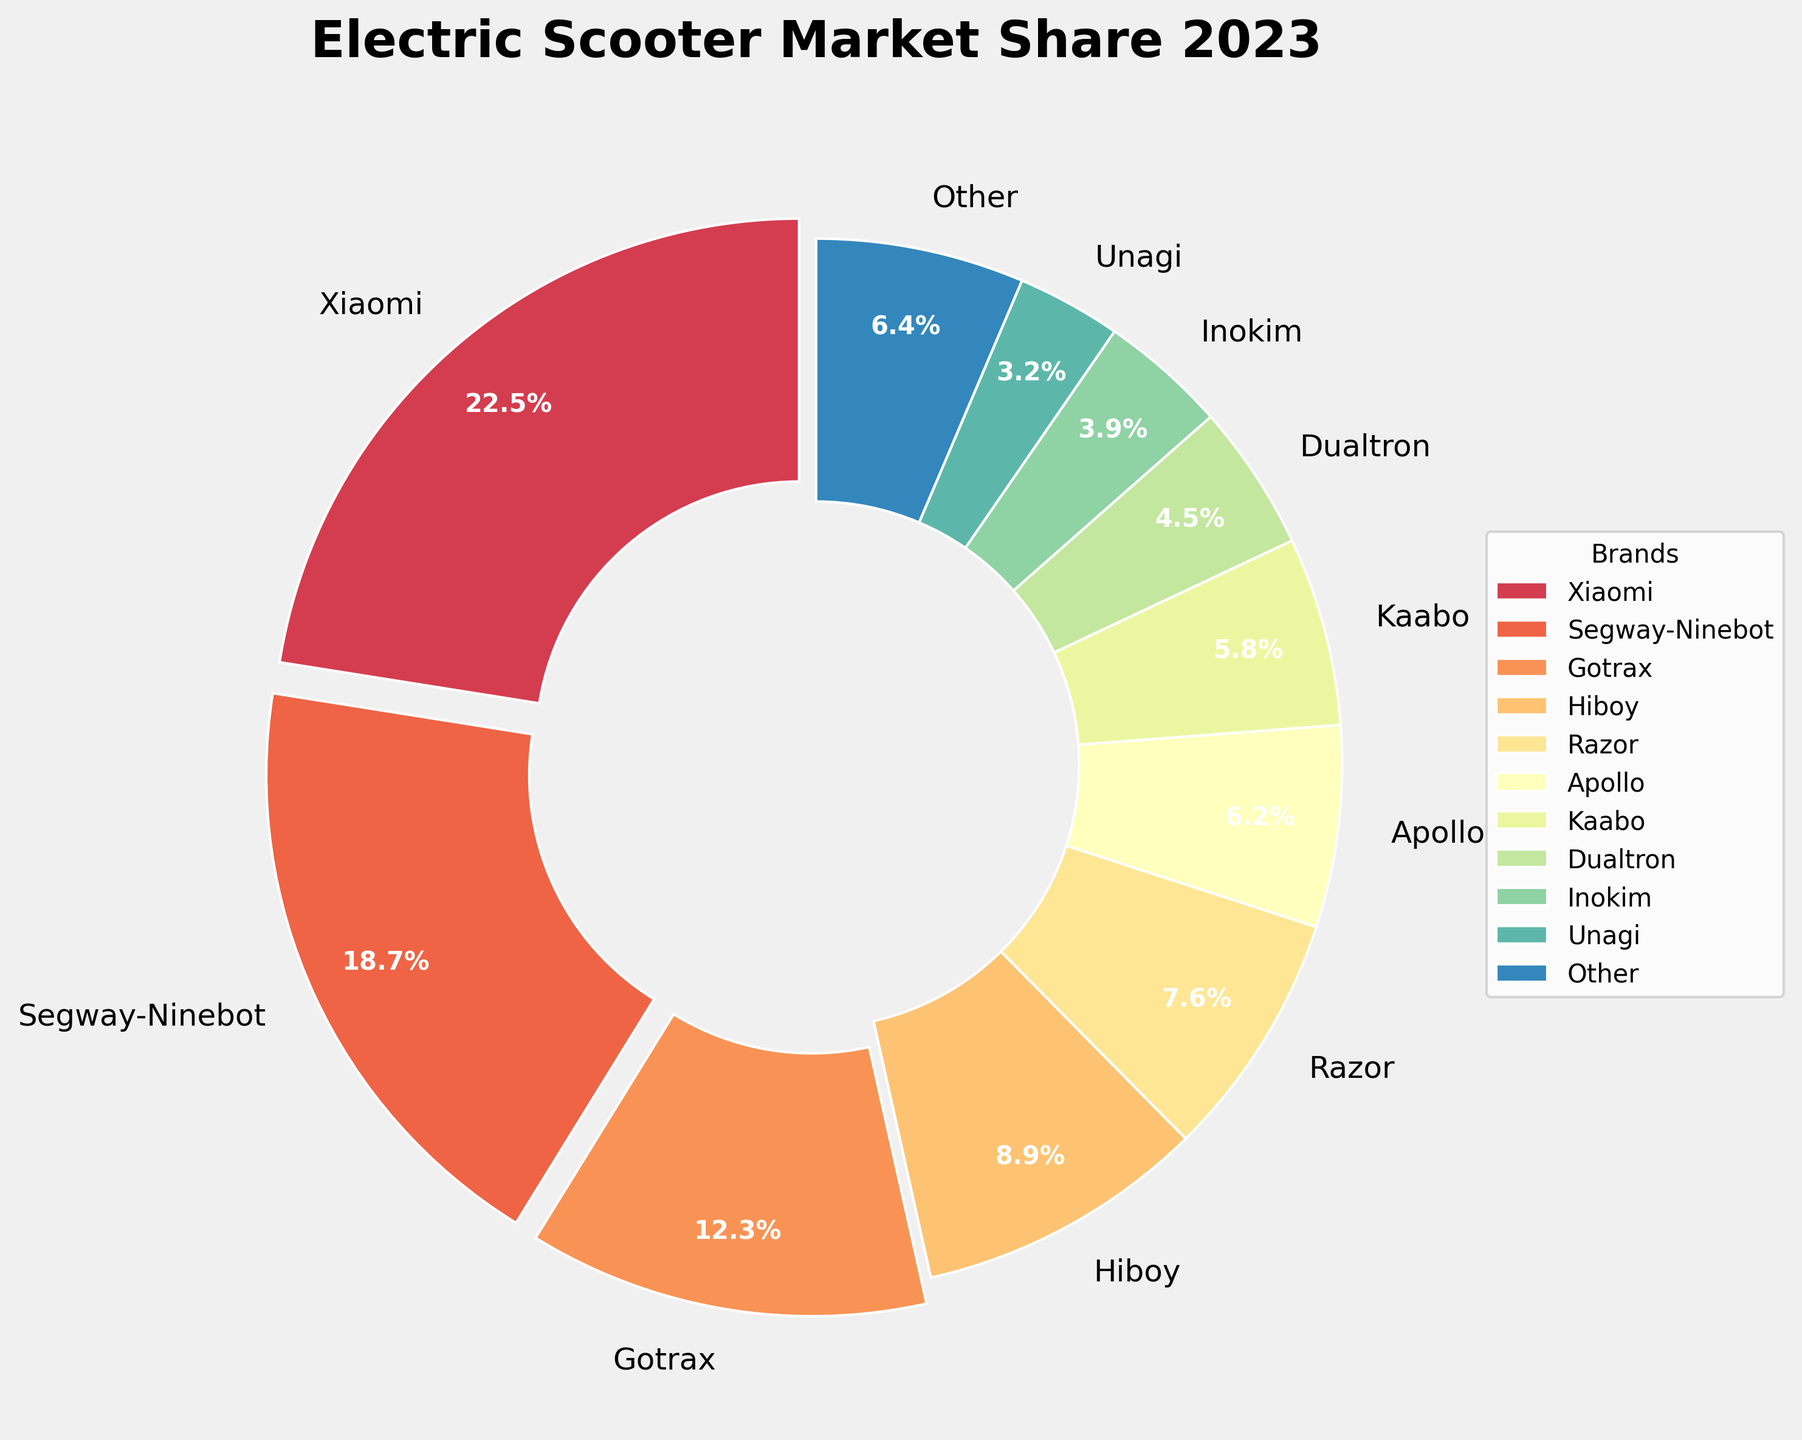How much market share do Xiaomi and Segway-Ninebot together have? Sum the market shares of Xiaomi and Segway-Ninebot, which are 22.5% and 18.7%. Adding them together gives 22.5 + 18.7 = 41.2%.
Answer: 41.2% Which brand has the smallest market share, and what is its value? Look for the brand with the smallest percentage in the pie chart. Unagi has the smallest market share at 3.2%.
Answer: Unagi, 3.2% What is the difference in market share between Gotrax and Segway-Ninebot? Subtract the market share of Gotrax (12.3%) from Segway-Ninebot (18.7%), so 18.7 - 12.3 = 6.4%.
Answer: 6.4% Which brands have a market share greater than 10% and what are their values? Identify the brands with more than 10% market share: Xiaomi and Segway-Ninebot, with values of 22.5% and 18.7%, respectively.
Answer: Xiaomi: 22.5%, Segway-Ninebot: 18.7% What is the total market share of brands with less than 5% each? Sum the market shares of Dualtron, Inokim, and Unagi, which are 4.5%, 3.9%, and 3.2%. Adding them together gives 4.5 + 3.9 + 3.2 = 11.6%.
Answer: 11.6% How does the market share of Hiboy compare to that of Razor? Hiboy has a market share of 8.9% whereas Razor has 7.6%. Hiboy's market share is greater than Razor's.
Answer: Hiboy > Razor Which color represents the Apollo brand in the pie chart? Each brand is represented by a distinct color; Apollo's sector is color-coded within the visual representation.
Answer: The specific shade seen for Apollo (users need to check the pie chart to identify the exact color) What is the average market share of the top three brands? The top three brands are Xiaomi, Segway-Ninebot, and Gotrax. Sum their market shares (22.5 + 18.7 + 12.3 = 53.5) and divide by 3 to get the average, 53.5 / 3 = 17.83%.
Answer: 17.83% List the brands that share the 'explode' effect in the pie chart. Brands with a market share greater than 10% have the 'explode' effect applied. These are Xiaomi and Segway-Ninebot.
Answer: Xiaomi, Segway-Ninebot What is the combined market share of brands that are not individually listed (i.e., "Other")? The market share for "Other" explicitly provided is 6.4%.
Answer: 6.4% 